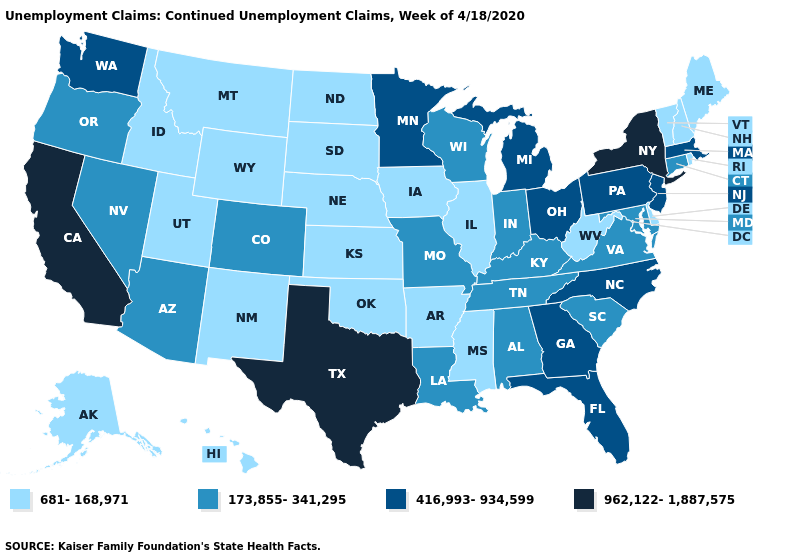Does the first symbol in the legend represent the smallest category?
Write a very short answer. Yes. Does the first symbol in the legend represent the smallest category?
Write a very short answer. Yes. What is the value of New Mexico?
Give a very brief answer. 681-168,971. Does Minnesota have a lower value than New York?
Be succinct. Yes. What is the value of Connecticut?
Write a very short answer. 173,855-341,295. What is the value of Virginia?
Short answer required. 173,855-341,295. Name the states that have a value in the range 681-168,971?
Keep it brief. Alaska, Arkansas, Delaware, Hawaii, Idaho, Illinois, Iowa, Kansas, Maine, Mississippi, Montana, Nebraska, New Hampshire, New Mexico, North Dakota, Oklahoma, Rhode Island, South Dakota, Utah, Vermont, West Virginia, Wyoming. Which states have the lowest value in the USA?
Short answer required. Alaska, Arkansas, Delaware, Hawaii, Idaho, Illinois, Iowa, Kansas, Maine, Mississippi, Montana, Nebraska, New Hampshire, New Mexico, North Dakota, Oklahoma, Rhode Island, South Dakota, Utah, Vermont, West Virginia, Wyoming. What is the value of Rhode Island?
Keep it brief. 681-168,971. What is the value of New York?
Be succinct. 962,122-1,887,575. What is the highest value in states that border Kentucky?
Give a very brief answer. 416,993-934,599. Name the states that have a value in the range 962,122-1,887,575?
Concise answer only. California, New York, Texas. Which states have the lowest value in the South?
Be succinct. Arkansas, Delaware, Mississippi, Oklahoma, West Virginia. What is the lowest value in the West?
Short answer required. 681-168,971. Does Arkansas have the same value as Pennsylvania?
Be succinct. No. 